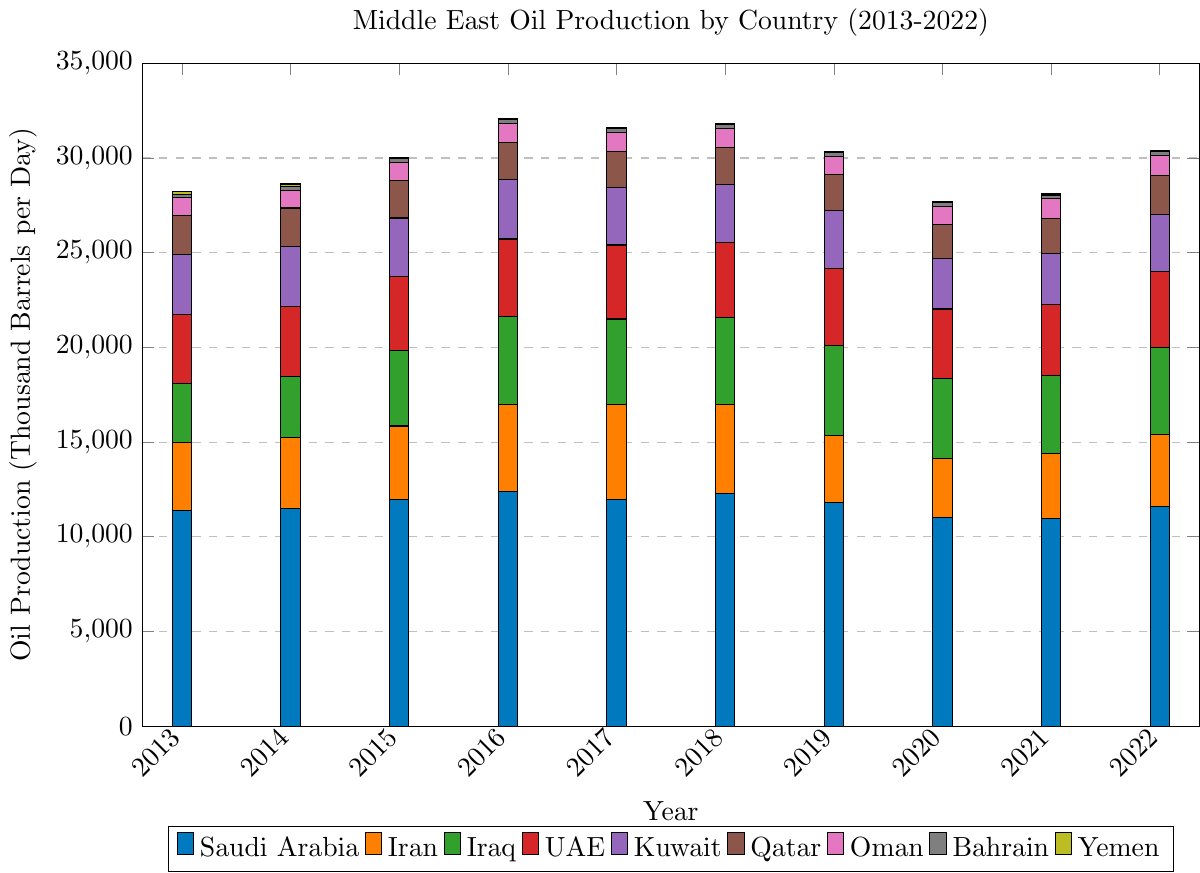what is the total oil production in 2016? Sum the production levels for 2016 from all countries: 12402 (Saudi Arabia) + 4602 (Iran) + 4647 (Iraq) + 4073 (UAE) + 3145 (Kuwait) + 1970 (Qatar) + 1004 (Oman) + 208 (Bahrain) + 27 (Yemen) = 32078
Answer: 32078 Which country had the highest production in 2019? Compare the bars for each country in 2019, the tallest bar is Saudi Arabia with 11832
Answer: Saudi Arabia How did Iran's oil production in 2018 compare to that in 2019? Look at the heights of the bars for Iran in 2018 and 2019, Iran produced 4715 in 2018 and 3537 in 2019. 4715 is greater than 3537
Answer: It decreased What was the average oil production of Kuwait over the decade? Sum Kuwait’s production from 2013-2022: 3126 + 3123 + 3068 + 3145 + 3025 + 3059 + 3017 + 2686 + 2716 + 3019 = 26984, then divide by 10: 26984/10 = 2698.4
Answer: 2698.4 Which year did Yemen have the lowest oil production? Compare the heights of the bars for Yemen across all years, the lowest bar is in 2016 with production of 27
Answer: 2016 Which country showed the most consistent production levels throughout the decade? Analyze the bars for each country to identify the one with minimal fluctuations. The UAE shows the least variation
Answer: UAE By how much did Saudi Arabia's production decrease from 2018 to 2020? Subtract the 2020 production from the 2018 production for Saudi Arabia: 12261 (2018) - 11039 (2020) = 1222
Answer: 1222 In which years did Bahrain's production surpass 200 thousand barrels per day? Check the heights of the bars for Bahrain, the bars are greater than 200 in 2017, 2018, 2022
Answer: 2017, 2018, 2022 